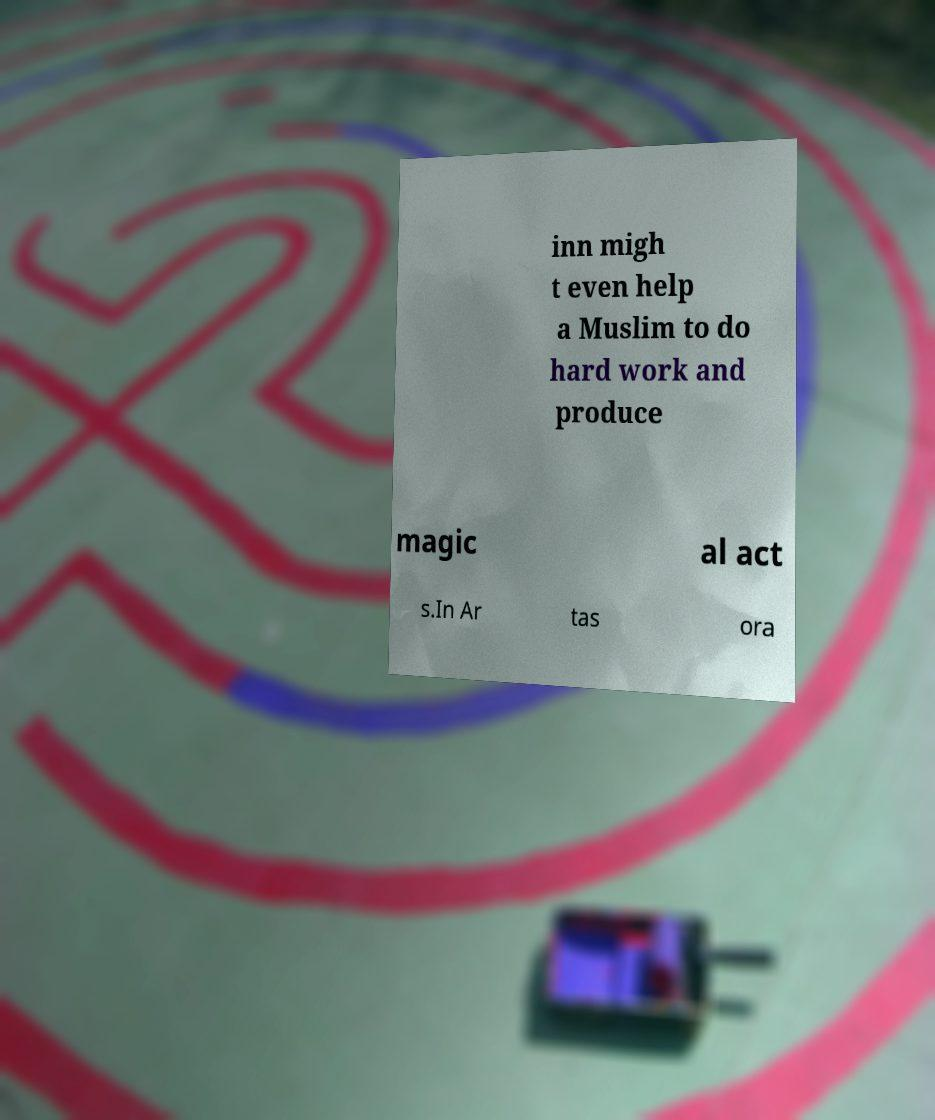For documentation purposes, I need the text within this image transcribed. Could you provide that? inn migh t even help a Muslim to do hard work and produce magic al act s.In Ar tas ora 